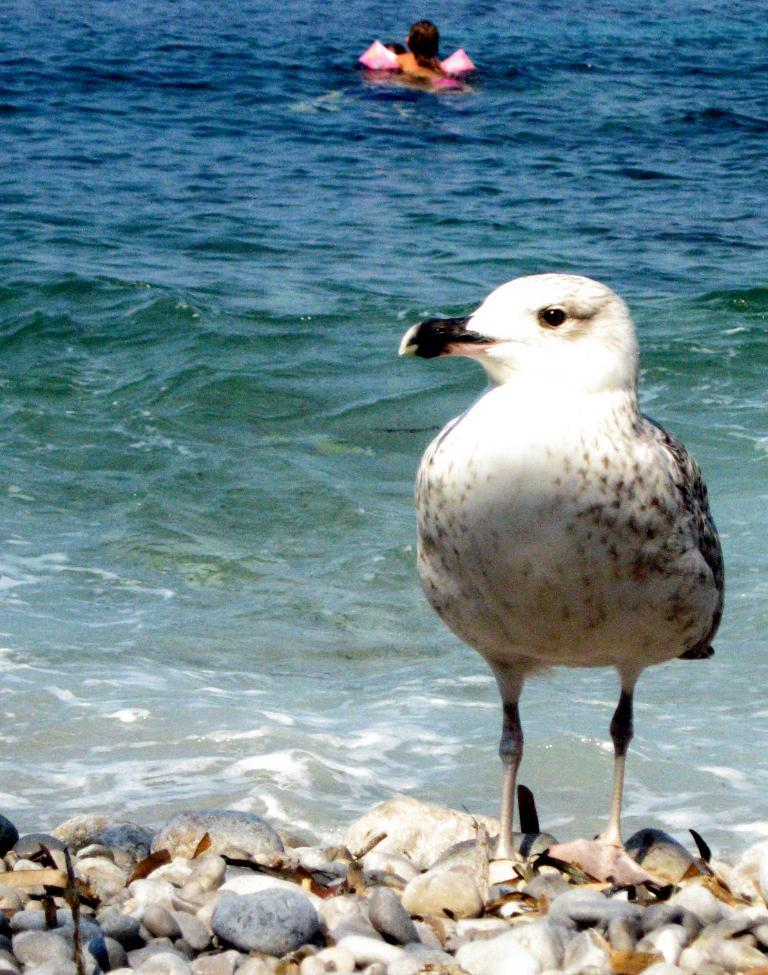What is on the stones in the image? There is a bird on the stones in the image. What can be seen in the background of the image? Water is visible in the image. What are the people in the image doing? People are swimming in the water. What type of spade is being used by the people swimming in the image? There is no spade visible in the image; people are swimming without any tools. What is the tendency of the river in the image? There is no river present in the image, so it's not possible to determine its tendency. 